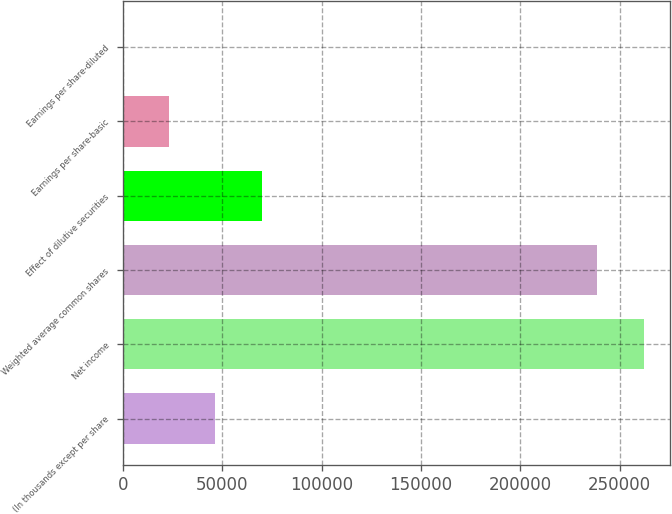Convert chart to OTSL. <chart><loc_0><loc_0><loc_500><loc_500><bar_chart><fcel>(In thousands except per share<fcel>Net income<fcel>Weighted average common shares<fcel>Effect of dilutive securities<fcel>Earnings per share-basic<fcel>Earnings per share-diluted<nl><fcel>46515.4<fcel>262012<fcel>238755<fcel>69772.6<fcel>23258.2<fcel>1.05<nl></chart> 